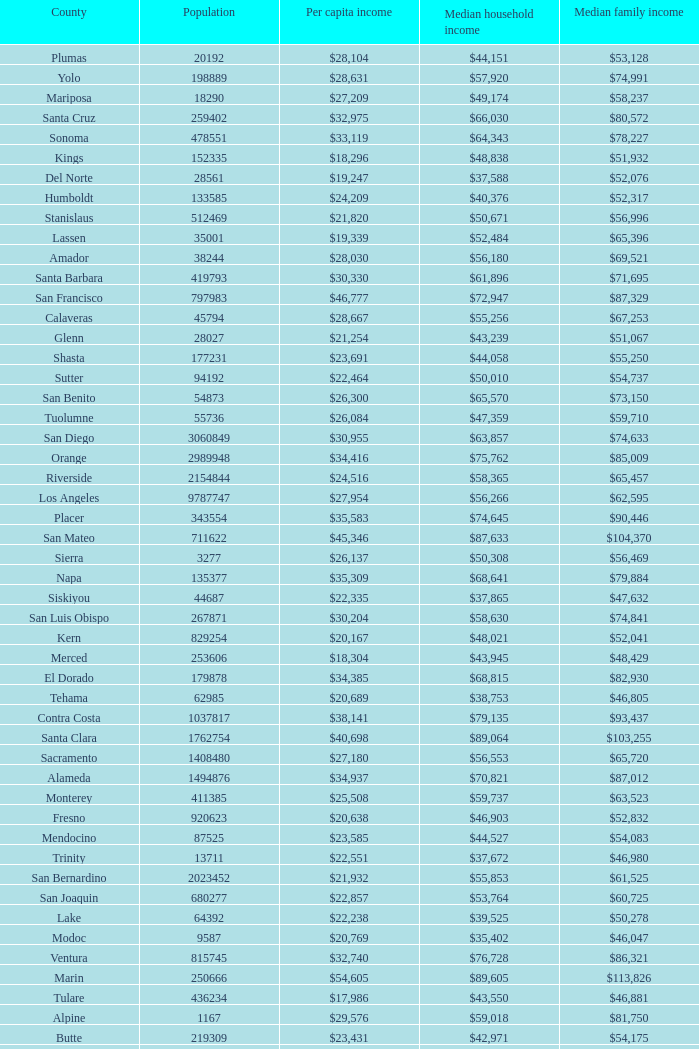What is the median household income of sacramento? $56,553. Could you parse the entire table as a dict? {'header': ['County', 'Population', 'Per capita income', 'Median household income', 'Median family income'], 'rows': [['Plumas', '20192', '$28,104', '$44,151', '$53,128'], ['Yolo', '198889', '$28,631', '$57,920', '$74,991'], ['Mariposa', '18290', '$27,209', '$49,174', '$58,237'], ['Santa Cruz', '259402', '$32,975', '$66,030', '$80,572'], ['Sonoma', '478551', '$33,119', '$64,343', '$78,227'], ['Kings', '152335', '$18,296', '$48,838', '$51,932'], ['Del Norte', '28561', '$19,247', '$37,588', '$52,076'], ['Humboldt', '133585', '$24,209', '$40,376', '$52,317'], ['Stanislaus', '512469', '$21,820', '$50,671', '$56,996'], ['Lassen', '35001', '$19,339', '$52,484', '$65,396'], ['Amador', '38244', '$28,030', '$56,180', '$69,521'], ['Santa Barbara', '419793', '$30,330', '$61,896', '$71,695'], ['San Francisco', '797983', '$46,777', '$72,947', '$87,329'], ['Calaveras', '45794', '$28,667', '$55,256', '$67,253'], ['Glenn', '28027', '$21,254', '$43,239', '$51,067'], ['Shasta', '177231', '$23,691', '$44,058', '$55,250'], ['Sutter', '94192', '$22,464', '$50,010', '$54,737'], ['San Benito', '54873', '$26,300', '$65,570', '$73,150'], ['Tuolumne', '55736', '$26,084', '$47,359', '$59,710'], ['San Diego', '3060849', '$30,955', '$63,857', '$74,633'], ['Orange', '2989948', '$34,416', '$75,762', '$85,009'], ['Riverside', '2154844', '$24,516', '$58,365', '$65,457'], ['Los Angeles', '9787747', '$27,954', '$56,266', '$62,595'], ['Placer', '343554', '$35,583', '$74,645', '$90,446'], ['San Mateo', '711622', '$45,346', '$87,633', '$104,370'], ['Sierra', '3277', '$26,137', '$50,308', '$56,469'], ['Napa', '135377', '$35,309', '$68,641', '$79,884'], ['Siskiyou', '44687', '$22,335', '$37,865', '$47,632'], ['San Luis Obispo', '267871', '$30,204', '$58,630', '$74,841'], ['Kern', '829254', '$20,167', '$48,021', '$52,041'], ['Merced', '253606', '$18,304', '$43,945', '$48,429'], ['El Dorado', '179878', '$34,385', '$68,815', '$82,930'], ['Tehama', '62985', '$20,689', '$38,753', '$46,805'], ['Contra Costa', '1037817', '$38,141', '$79,135', '$93,437'], ['Santa Clara', '1762754', '$40,698', '$89,064', '$103,255'], ['Sacramento', '1408480', '$27,180', '$56,553', '$65,720'], ['Alameda', '1494876', '$34,937', '$70,821', '$87,012'], ['Monterey', '411385', '$25,508', '$59,737', '$63,523'], ['Fresno', '920623', '$20,638', '$46,903', '$52,832'], ['Mendocino', '87525', '$23,585', '$44,527', '$54,083'], ['Trinity', '13711', '$22,551', '$37,672', '$46,980'], ['San Bernardino', '2023452', '$21,932', '$55,853', '$61,525'], ['San Joaquin', '680277', '$22,857', '$53,764', '$60,725'], ['Lake', '64392', '$22,238', '$39,525', '$50,278'], ['Modoc', '9587', '$20,769', '$35,402', '$46,047'], ['Ventura', '815745', '$32,740', '$76,728', '$86,321'], ['Marin', '250666', '$54,605', '$89,605', '$113,826'], ['Tulare', '436234', '$17,986', '$43,550', '$46,881'], ['Alpine', '1167', '$29,576', '$59,018', '$81,750'], ['Butte', '219309', '$23,431', '$42,971', '$54,175'], ['Solano', '411620', '$29,367', '$69,914', '$79,316'], ['Nevada', '98392', '$31,607', '$58,077', '$69,807'], ['Colusa', '21297', '$21,271', '$49,558', '$55,063'], ['Madera', '149611', '$18,817', '$47,724', '$51,658'], ['Inyo', '18457', '$27,532', '$49,571', '$68,204'], ['Mono', '14016', '$28,789', '$60,469', '$78,079'], ['Imperial', '171343', '$16,593', '$39,402', '$43,769']]} 